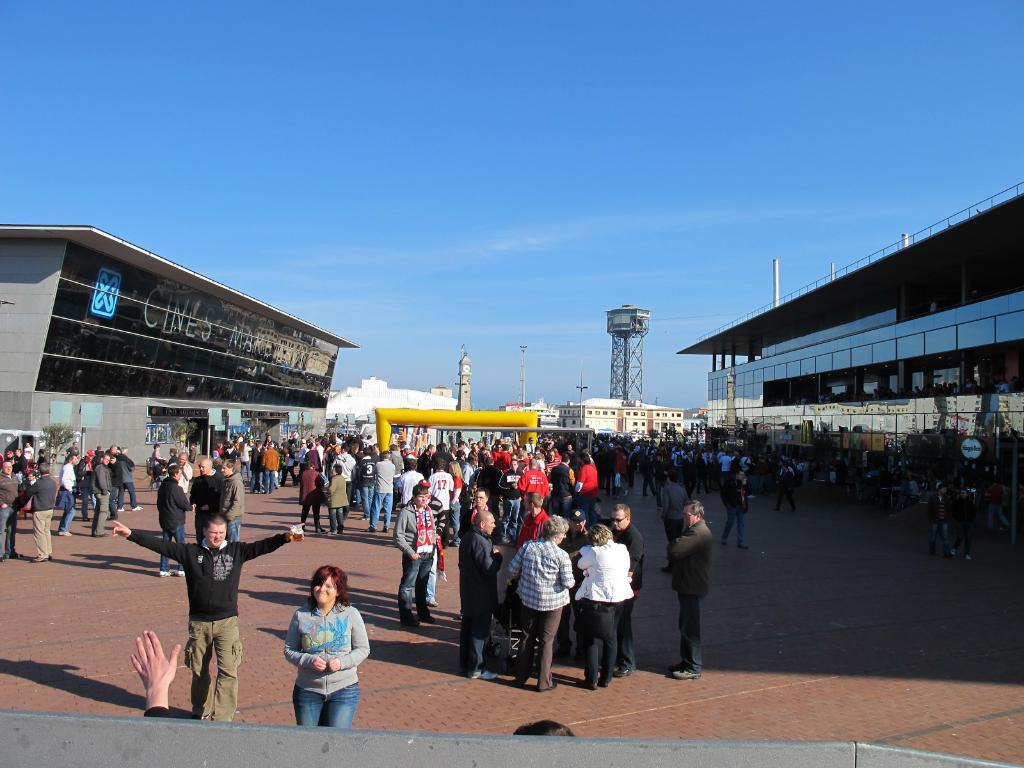What is happening in the image? There are people standing on the surface in the image. What can be seen on the left side of the image? There are buildings on the left side of the image. What can be seen on the right side of the image? There are buildings on the right side of the image. What is the price of the rod in the image? There is no rod present in the image. What event is taking place in the image? The image does not depict a specific event; it simply shows people standing on a surface with buildings on both sides. 